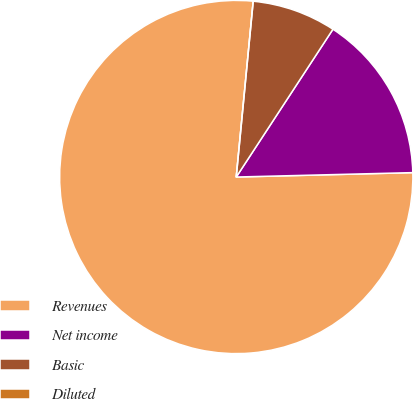<chart> <loc_0><loc_0><loc_500><loc_500><pie_chart><fcel>Revenues<fcel>Net income<fcel>Basic<fcel>Diluted<nl><fcel>76.92%<fcel>15.38%<fcel>7.69%<fcel>0.0%<nl></chart> 